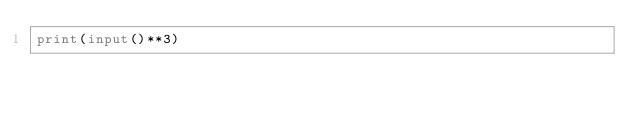<code> <loc_0><loc_0><loc_500><loc_500><_Python_>print(input()**3)</code> 